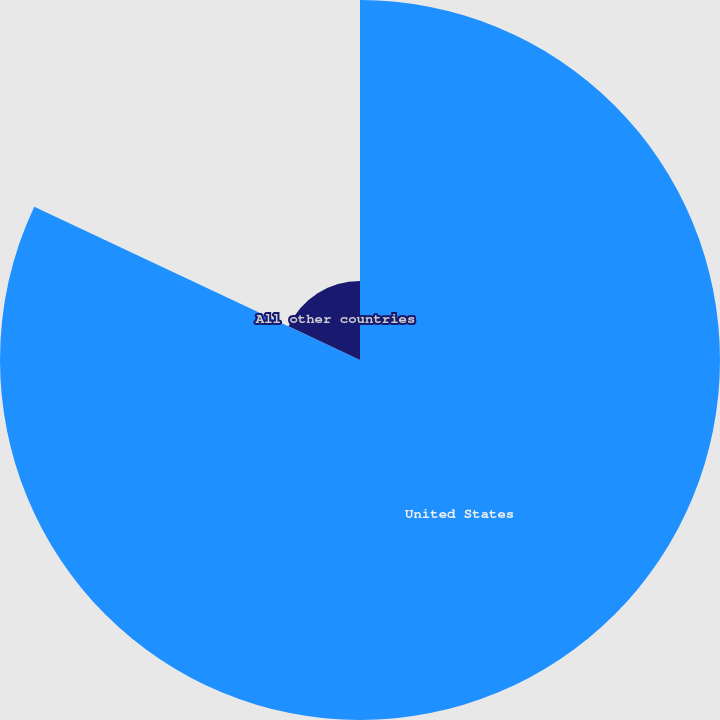Convert chart to OTSL. <chart><loc_0><loc_0><loc_500><loc_500><pie_chart><fcel>United States<fcel>All other countries<nl><fcel>82.0%<fcel>18.0%<nl></chart> 